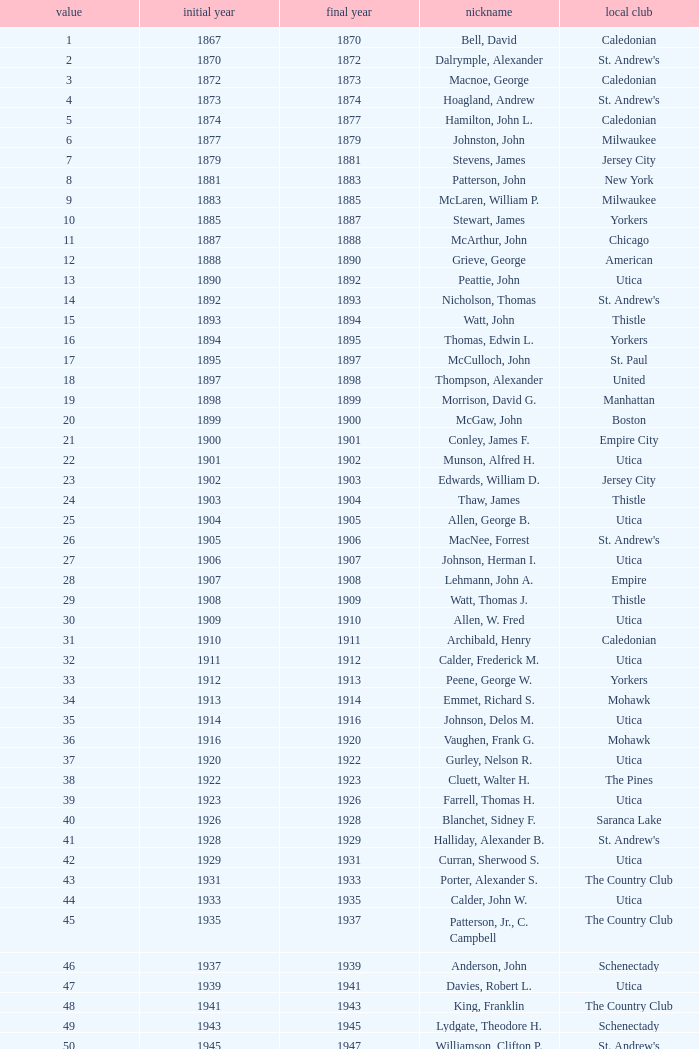Which Number has a Year Start smaller than 1874, and a Year End larger than 1873? 4.0. 